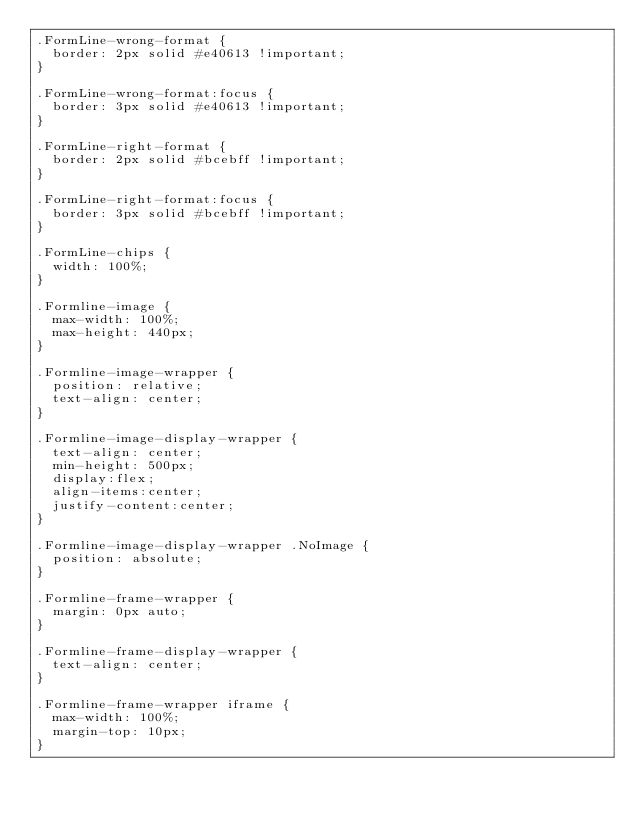<code> <loc_0><loc_0><loc_500><loc_500><_CSS_>.FormLine-wrong-format {
	border: 2px solid #e40613 !important;
}

.FormLine-wrong-format:focus {
	border: 3px solid #e40613 !important;
}

.FormLine-right-format {
	border: 2px solid #bcebff !important;
}

.FormLine-right-format:focus {
	border: 3px solid #bcebff !important;
}

.FormLine-chips {
	width: 100%;
}

.Formline-image {
	max-width: 100%;
	max-height: 440px;
}

.Formline-image-wrapper {
	position: relative;
	text-align: center;
}

.Formline-image-display-wrapper {
	text-align: center;
	min-height: 500px;
	display:flex;
	align-items:center;
	justify-content:center;
}

.Formline-image-display-wrapper .NoImage {
	position: absolute;
}

.Formline-frame-wrapper {
	margin: 0px auto;
}

.Formline-frame-display-wrapper {
	text-align: center;
}

.Formline-frame-wrapper iframe {
	max-width: 100%;
	margin-top: 10px;
}</code> 